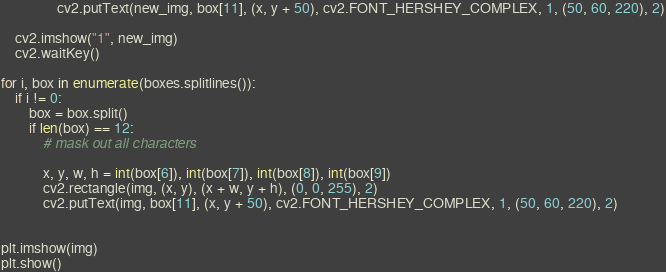Convert code to text. <code><loc_0><loc_0><loc_500><loc_500><_Python_>                cv2.putText(new_img, box[11], (x, y + 50), cv2.FONT_HERSHEY_COMPLEX, 1, (50, 60, 220), 2)

    cv2.imshow("1", new_img)
    cv2.waitKey()

for i, box in enumerate(boxes.splitlines()):
    if i != 0:
        box = box.split()
        if len(box) == 12:
            # mask out all characters

            x, y, w, h = int(box[6]), int(box[7]), int(box[8]), int(box[9])
            cv2.rectangle(img, (x, y), (x + w, y + h), (0, 0, 255), 2)
            cv2.putText(img, box[11], (x, y + 50), cv2.FONT_HERSHEY_COMPLEX, 1, (50, 60, 220), 2)


plt.imshow(img)
plt.show()
</code> 